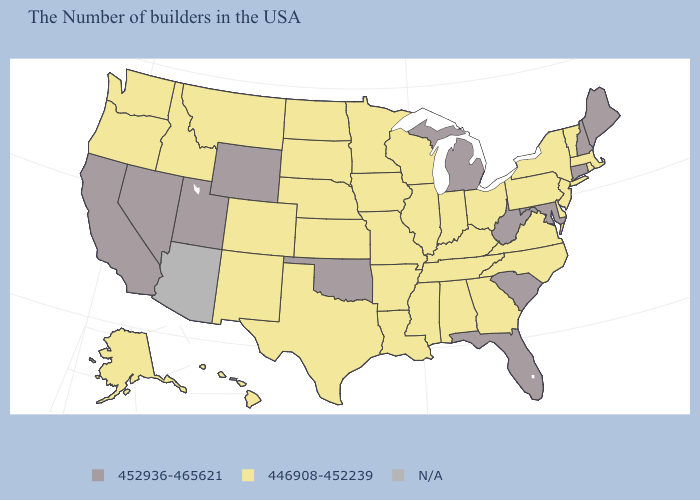Name the states that have a value in the range N/A?
Short answer required. Arizona. Name the states that have a value in the range 446908-452239?
Be succinct. Massachusetts, Rhode Island, Vermont, New York, New Jersey, Delaware, Pennsylvania, Virginia, North Carolina, Ohio, Georgia, Kentucky, Indiana, Alabama, Tennessee, Wisconsin, Illinois, Mississippi, Louisiana, Missouri, Arkansas, Minnesota, Iowa, Kansas, Nebraska, Texas, South Dakota, North Dakota, Colorado, New Mexico, Montana, Idaho, Washington, Oregon, Alaska, Hawaii. What is the value of Florida?
Write a very short answer. 452936-465621. What is the value of New York?
Keep it brief. 446908-452239. What is the value of Vermont?
Concise answer only. 446908-452239. What is the value of Rhode Island?
Keep it brief. 446908-452239. Does Nevada have the highest value in the USA?
Keep it brief. Yes. Which states have the highest value in the USA?
Concise answer only. Maine, New Hampshire, Connecticut, Maryland, South Carolina, West Virginia, Florida, Michigan, Oklahoma, Wyoming, Utah, Nevada, California. Which states hav the highest value in the West?
Answer briefly. Wyoming, Utah, Nevada, California. Name the states that have a value in the range N/A?
Be succinct. Arizona. Among the states that border West Virginia , does Maryland have the lowest value?
Short answer required. No. 